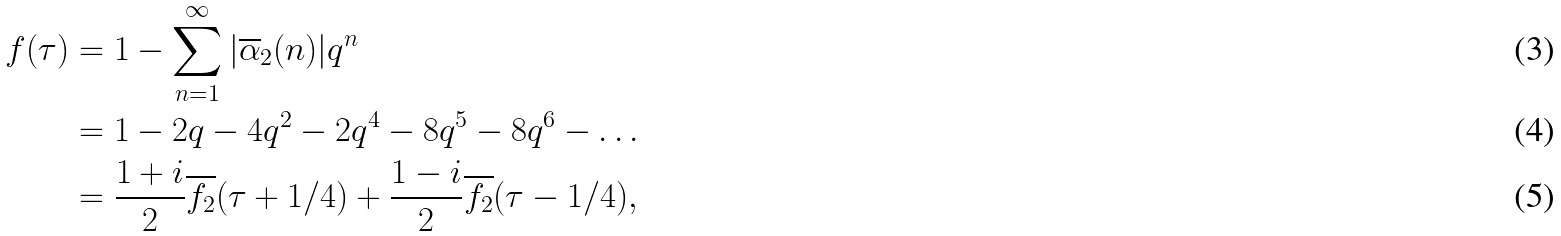<formula> <loc_0><loc_0><loc_500><loc_500>f ( \tau ) & = 1 - \sum _ { n = 1 } ^ { \infty } | \overline { \alpha } _ { 2 } ( n ) | q ^ { n } \\ & = 1 - 2 q - 4 q ^ { 2 } - 2 q ^ { 4 } - 8 q ^ { 5 } - 8 q ^ { 6 } - \dots \\ & = \frac { 1 + i } { 2 } \overline { f _ { 2 } } ( \tau + 1 / 4 ) + \frac { 1 - i } { 2 } \overline { f _ { 2 } } ( \tau - 1 / 4 ) ,</formula> 